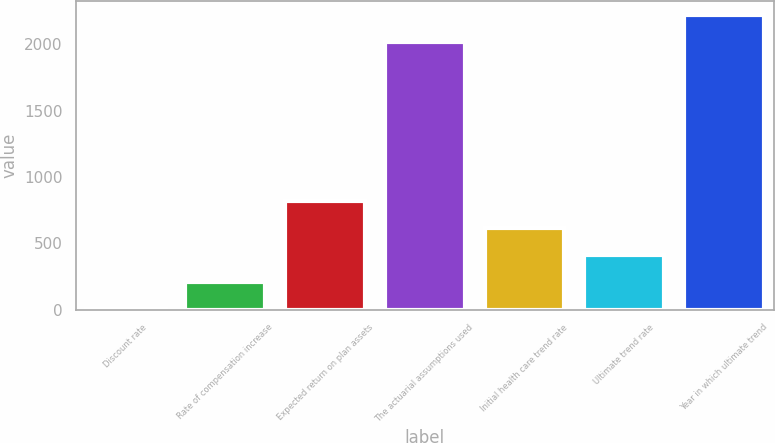Convert chart to OTSL. <chart><loc_0><loc_0><loc_500><loc_500><bar_chart><fcel>Discount rate<fcel>Rate of compensation increase<fcel>Expected return on plan assets<fcel>The actuarial assumptions used<fcel>Initial health care trend rate<fcel>Ultimate trend rate<fcel>Year in which ultimate trend<nl><fcel>4.1<fcel>207.49<fcel>817.66<fcel>2015<fcel>614.27<fcel>410.88<fcel>2218.39<nl></chart> 